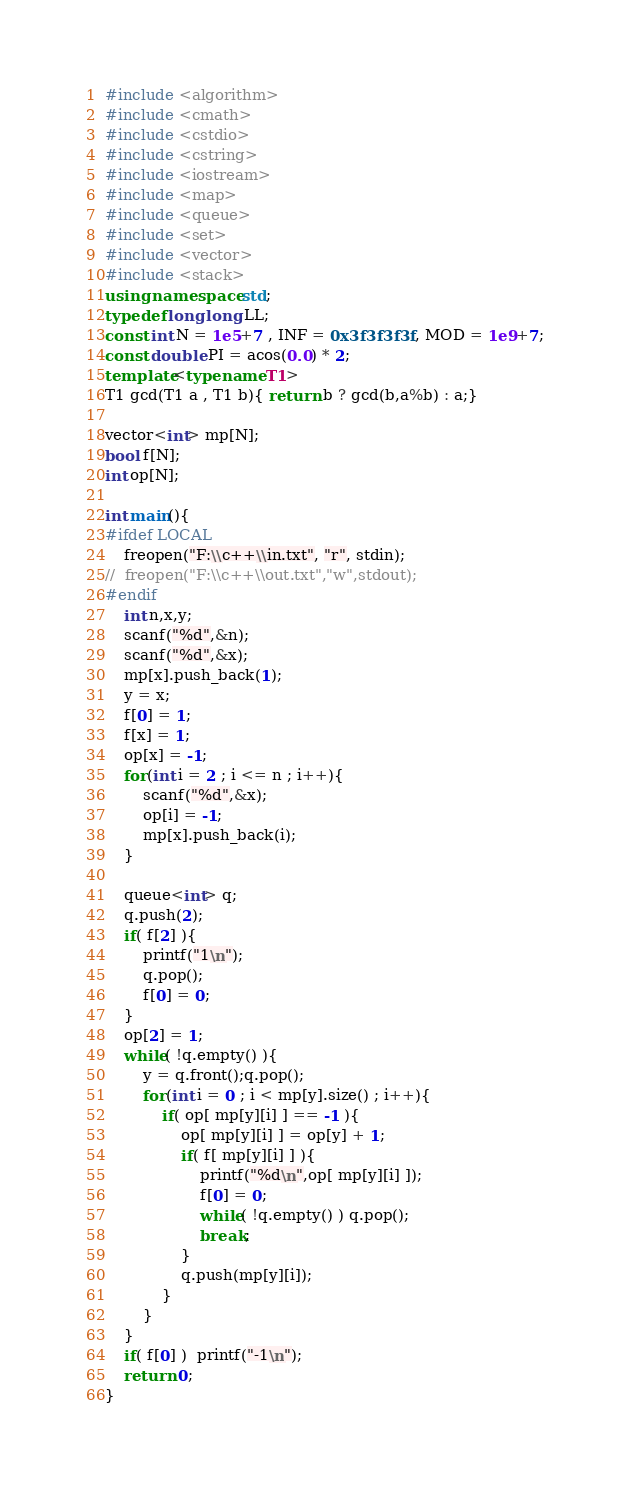Convert code to text. <code><loc_0><loc_0><loc_500><loc_500><_C++_>#include <algorithm>
#include <cmath>
#include <cstdio>
#include <cstring>
#include <iostream>
#include <map>
#include <queue>
#include <set>
#include <vector>
#include <stack>
using namespace std;
typedef long long LL;
const int N = 1e5+7 , INF = 0x3f3f3f3f , MOD = 1e9+7;
const double PI = acos(0.0) * 2;
template<typename T1>
T1 gcd(T1 a , T1 b){ return b ? gcd(b,a%b) : a;}

vector<int> mp[N];
bool f[N];
int op[N];

int main(){
#ifdef LOCAL
    freopen("F:\\c++\\in.txt", "r", stdin);
//  freopen("F:\\c++\\out.txt","w",stdout);
#endif
    int n,x,y;
    scanf("%d",&n);
    scanf("%d",&x);
    mp[x].push_back(1);
    y = x;
    f[0] = 1;
    f[x] = 1;
    op[x] = -1;
    for(int i = 2 ; i <= n ; i++){
        scanf("%d",&x);
        op[i] = -1;
        mp[x].push_back(i);
    }

    queue<int> q;
    q.push(2);
    if( f[2] ){
        printf("1\n");
        q.pop();
        f[0] = 0;
    }
    op[2] = 1;
    while( !q.empty() ){
        y = q.front();q.pop();
        for(int i = 0 ; i < mp[y].size() ; i++){
            if( op[ mp[y][i] ] == -1 ){
                op[ mp[y][i] ] = op[y] + 1;
                if( f[ mp[y][i] ] ){
                    printf("%d\n",op[ mp[y][i] ]);
                    f[0] = 0;
                    while( !q.empty() ) q.pop();
                    break;
                }
                q.push(mp[y][i]);
            }
        }
    }
    if( f[0] )  printf("-1\n");
    return 0;
}
</code> 